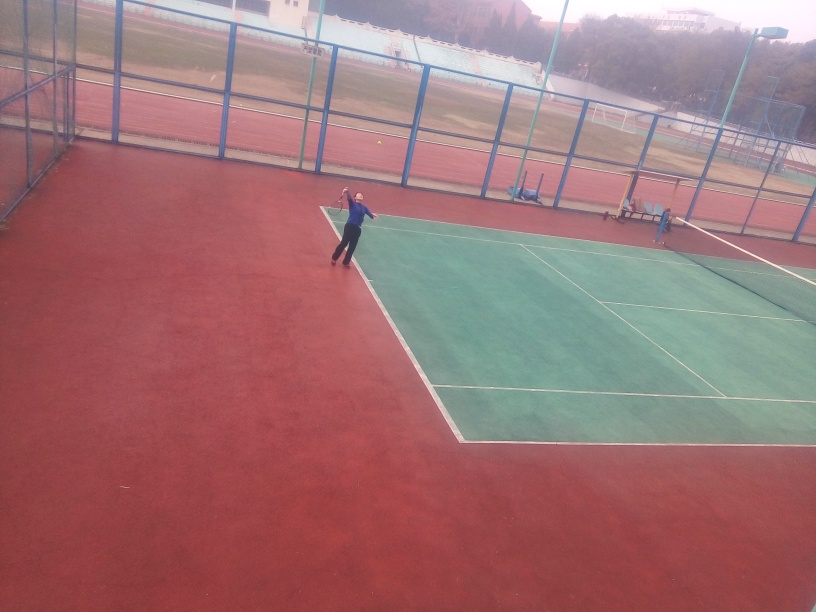Are the main subjects somewhat blurry? Yes, upon closer examination, it appears that the main subjects—the tennis players and the environment around them—are indeed somewhat blurry. This might be due to motion, camera shake, or focus issues when the photo was taken. 